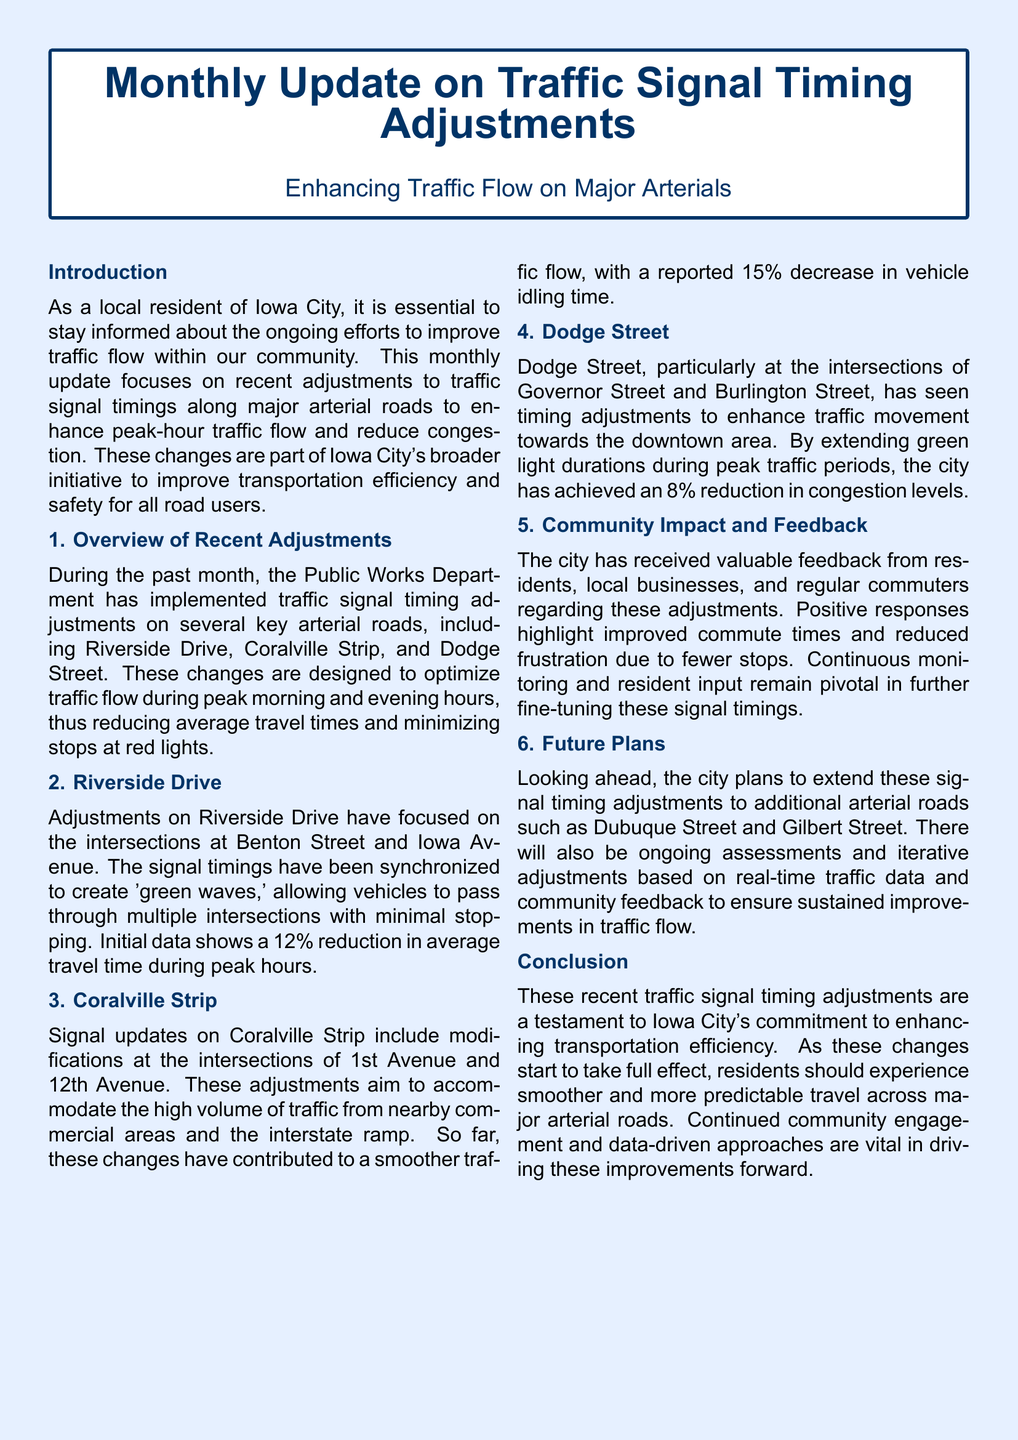what are the key roads mentioned in the adjustments? The document lists Riverside Drive, Coralville Strip, and Dodge Street as the key arterial roads with adjustments.
Answer: Riverside Drive, Coralville Strip, Dodge Street what was the reduction in average travel time on Riverside Drive? The document states that there was a 12% reduction in average travel time during peak hours on Riverside Drive.
Answer: 12% which intersection on Coralville Strip had signal updates? The document mentions 1st Avenue and 12th Avenue as the intersections with signal updates on Coralville Strip.
Answer: 1st Avenue and 12th Avenue how much has vehicle idling time decreased on Coralville Strip? The reported decrease in vehicle idling time on Coralville Strip due to signal adjustments is 15%.
Answer: 15% what type of feedback has the city received about the adjustments? The document indicates that feedback from residents, local businesses, and commuters has been generally positive, highlighting improved commute times.
Answer: Positive feedback which streets are planned for future signal timing adjustments? The city plans to extend signal timing adjustments to Dubuque Street and Gilbert Street in the future.
Answer: Dubuque Street, Gilbert Street what percentage reduction in congestion levels was achieved on Dodge Street? The document reports an 8% reduction in congestion levels on Dodge Street due to timing adjustments.
Answer: 8% what is the primary goal of these traffic signal timing adjustments? The main goal of the adjustments is to enhance traffic flow and reduce congestion on major arterial roads.
Answer: Enhance traffic flow how are the traffic signal adjustments expected to impact residents? The expected impact of the traffic signal adjustments is smoother and more predictable travel across major arterial roads for residents.
Answer: Smoother travel 